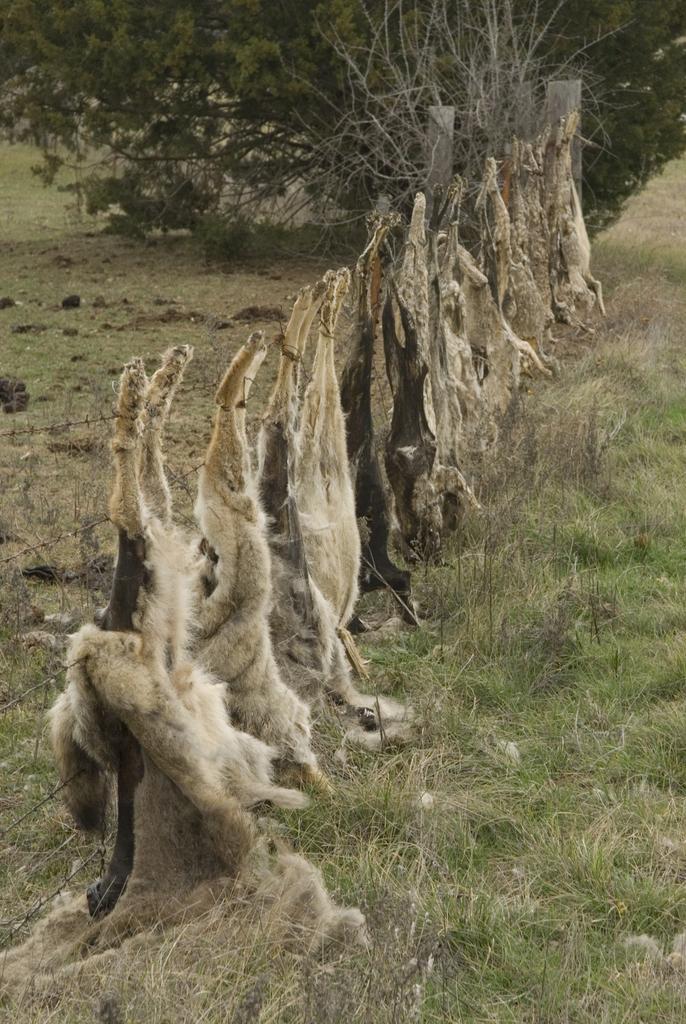Please provide a concise description of this image. In this picture we can see many animals which are changed to this fencing. At the bottom we can see green grass. At the top there is a tree. 